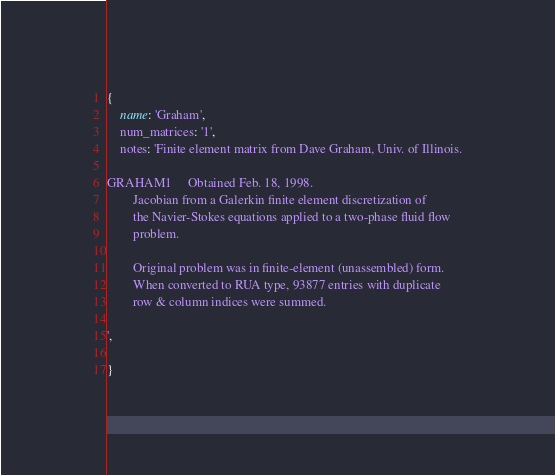<code> <loc_0><loc_0><loc_500><loc_500><_Ruby_>{
    name: 'Graham',
    num_matrices: '1',
    notes: 'Finite element matrix from Dave Graham, Univ. of Illinois.

GRAHAM1		Obtained Feb. 18, 1998.
		Jacobian from a Galerkin finite element discretization of
		the Navier-Stokes equations applied to a two-phase fluid flow
		problem.

		Original problem was in finite-element (unassembled) form.
		When converted to RUA type, 93877 entries with duplicate
		row & column indices were summed.

',

}

</code> 